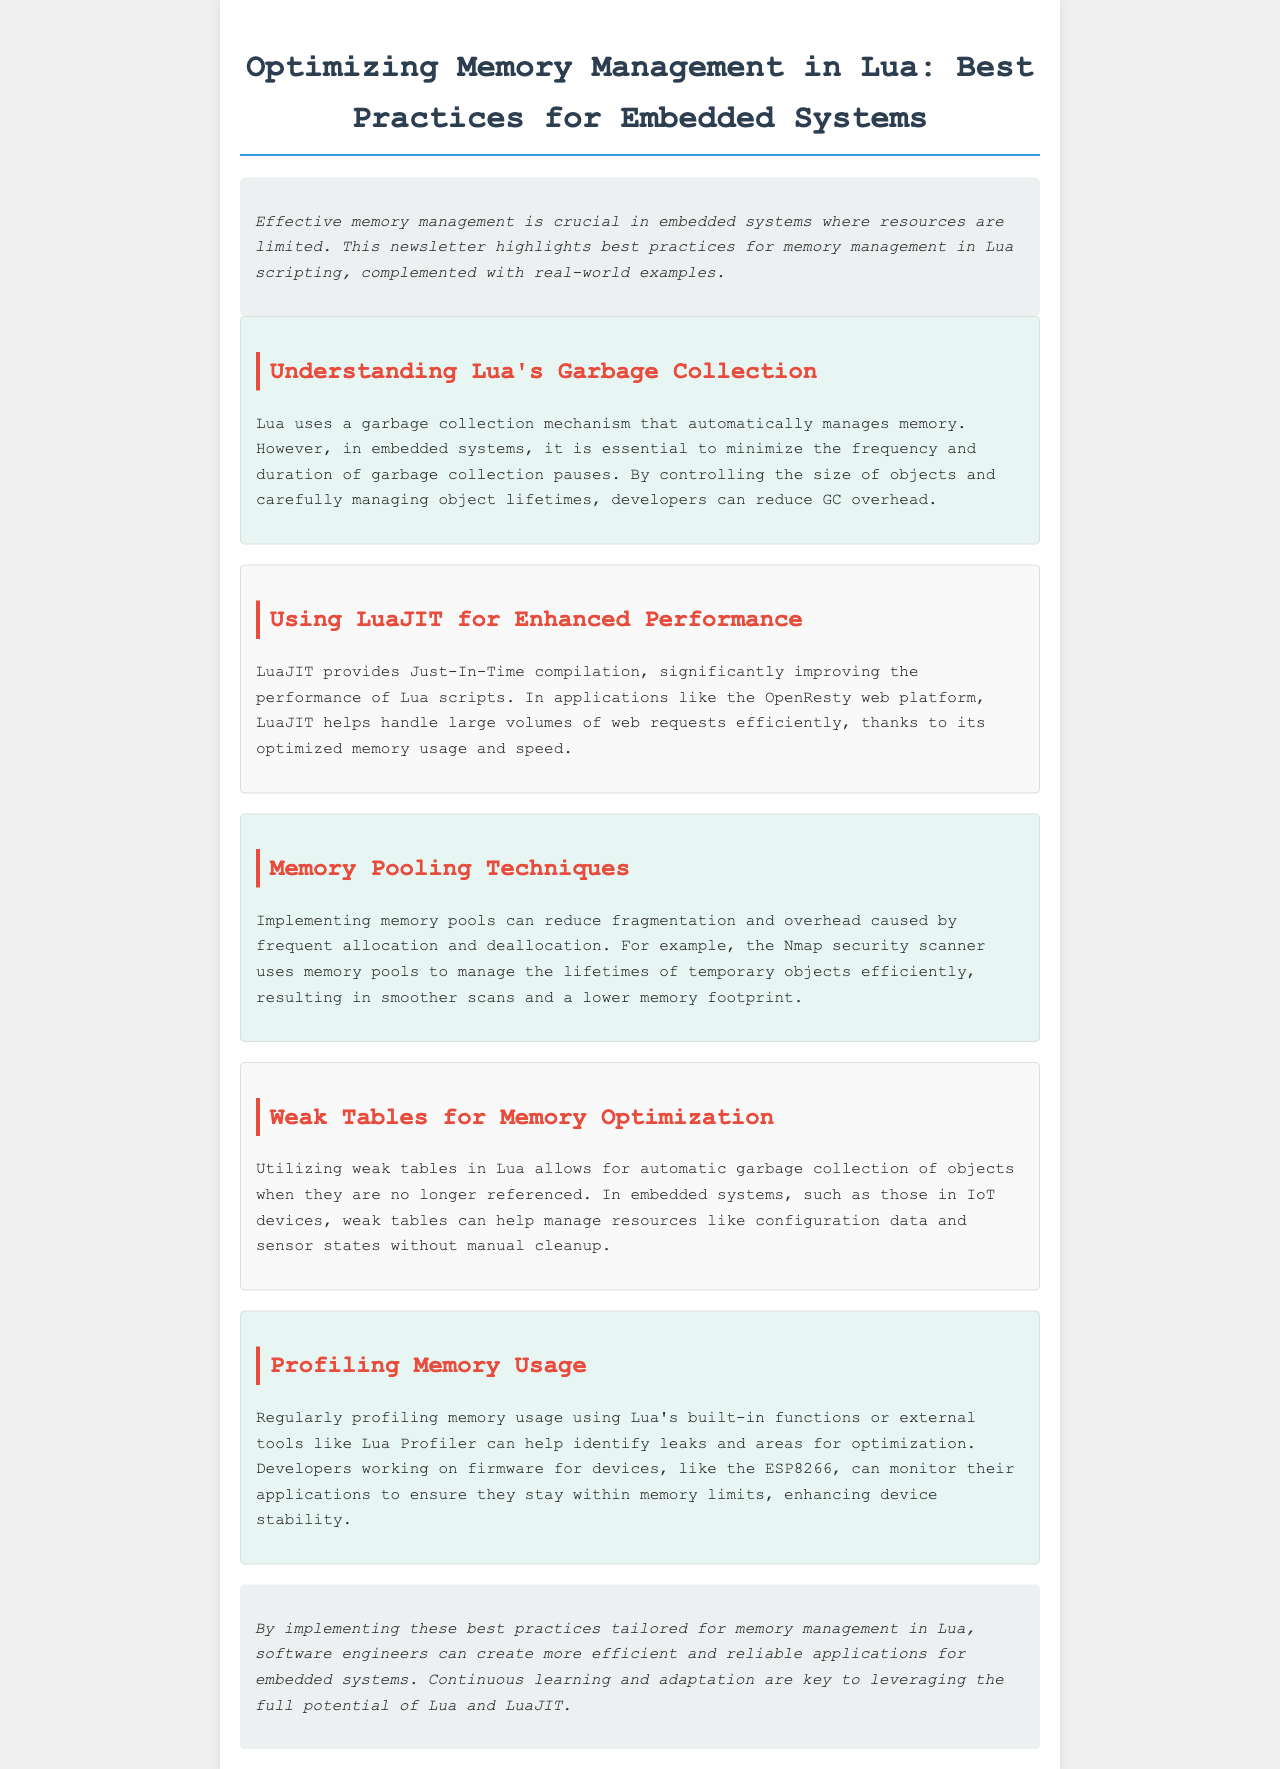What is the main topic of the newsletter? The main topic is about best practices for memory management in Lua scripting, specifically for embedded systems.
Answer: Best practices for memory management in Lua scripting Which JavaScript engine is mentioned for enhanced performance? The JavaScript engine mentioned is LuaJIT, which provides Just-In-Time compilation.
Answer: LuaJIT What technique does Nmap use for memory management? Nmap uses memory pooling techniques to manage the lifetimes of temporary objects efficiently.
Answer: Memory pooling What type of tables can help with automatic garbage collection? Weak tables can help manage resources and allow for automatic garbage collection of objects.
Answer: Weak tables What device is referenced regarding profiling memory usage? The ESP8266 is referenced as a device where developers can monitor applications to ensure they stay within memory limits.
Answer: ESP8266 How does Lua's garbage collection mechanism work in embedded systems? Lua's garbage collection automatically manages memory, but it is important to minimize the frequency and duration of GC pauses in embedded systems.
Answer: Automatically manages memory What is stated as crucial in embedded systems? Effective memory management is crucial in embedded systems where resources are limited.
Answer: Effective memory management What is emphasized as key for leveraging Lua and LuaJIT? Continuous learning and adaptation are emphasized as key.
Answer: Continuous learning and adaptation 